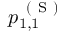<formula> <loc_0><loc_0><loc_500><loc_500>p _ { 1 , 1 } ^ { ( S ) }</formula> 